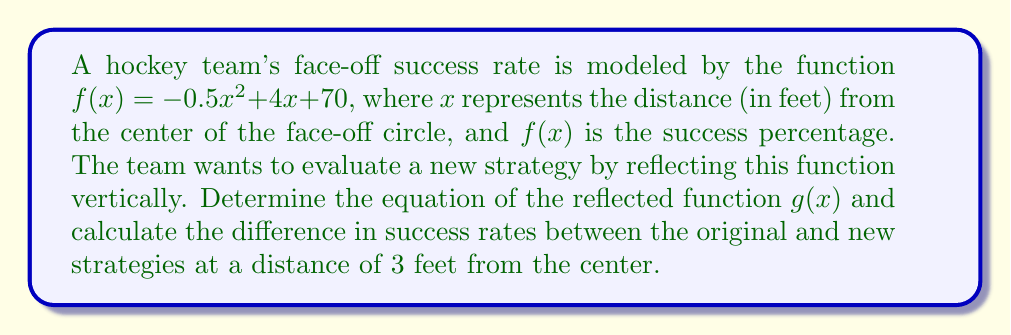Solve this math problem. 1) To reflect $f(x)$ vertically, we need to negate the entire function. The equation for $g(x)$ becomes:

   $g(x) = -f(x) = -(-0.5x^2 + 4x + 70) = 0.5x^2 - 4x - 70$

2) Now, let's calculate the success rate for the original strategy at $x = 3$:

   $f(3) = -0.5(3)^2 + 4(3) + 70$
   $= -0.5(9) + 12 + 70$
   $= -4.5 + 12 + 70 = 77.5\%$

3) Calculate the success rate for the new strategy at $x = 3$:

   $g(3) = 0.5(3)^2 - 4(3) - 70$
   $= 0.5(9) - 12 - 70$
   $= 4.5 - 12 - 70 = -77.5\%$

4) Find the difference between the original and new strategies:

   Difference = $f(3) - g(3) = 77.5 - (-77.5) = 155\%$

This significant difference suggests that the original strategy is much more effective at this distance.
Answer: 155% 